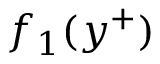<formula> <loc_0><loc_0><loc_500><loc_500>f _ { 1 } ( y ^ { + } )</formula> 